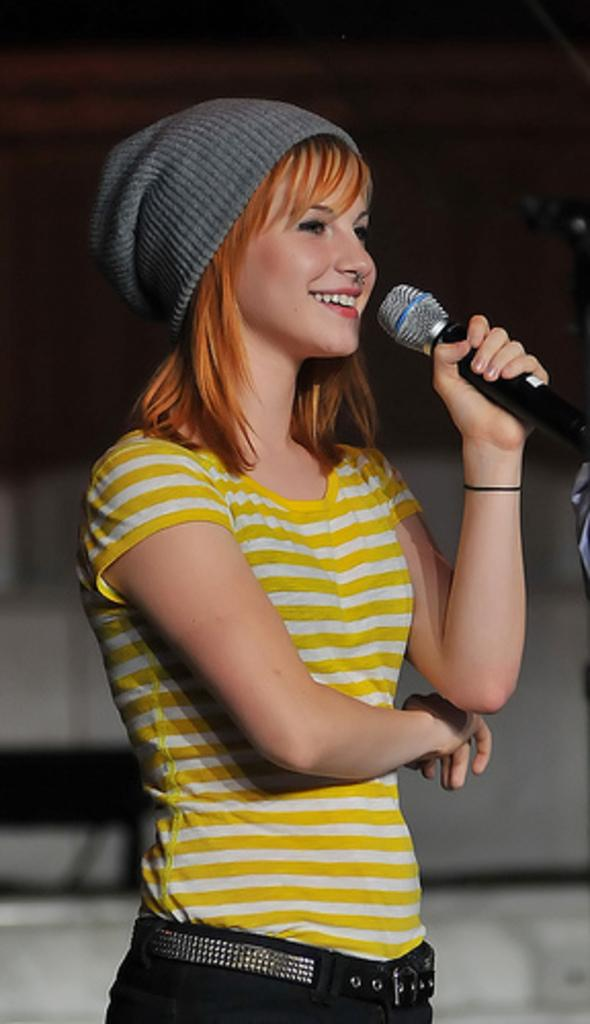Who is the main subject in the image? There is a woman in the image. What is the woman doing in the image? The woman is standing and smiling. What object is the woman holding in her hand? The woman is holding a microphone in her hand. What can be observed about the background of the image? The background of the image is dark. Is there a wall of smoke behind the woman in the image? There is no wall of smoke present in the image. 